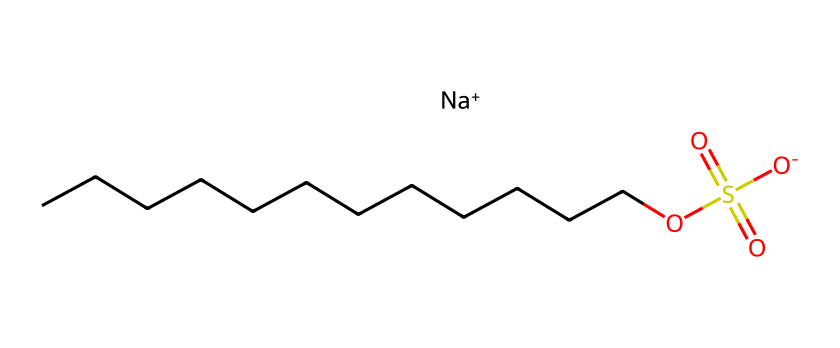What is the molecular formula of sodium dodecyl sulfate? The SMILES representation shows the structure includes sodium (Na), sulfur (S), oxygen (O), and carbon (C). Counting carbon atoms gives 12, so the molecular formula is C12H25NaO4S.
Answer: C12H25NaO4S How many carbon atoms are present in the structure? By examining the hydrophobic tail in the SMILES, which is represented by "CCCCCCCCCCCC," we can see there are 12 carbon atoms.
Answer: 12 What type of chemical bond connects the sodium ion to the sulfate group? The presence of [Na+] indicates an ionic bond between the positively charged sodium ion and the negatively charged sulfate group represented by [O-]S(=O)(=O)O.
Answer: ionic bond How many oxygen atoms are in the sulfate group? The sulfate part of the structure is indicated by "S(=O)(=O)O," which shows three oxygen atoms directly bonded to the sulfur atom, contributing to the sulfate group.
Answer: 4 What is the charge of the sodium ion in sodium dodecyl sulfate? The representation "[Na+]" clearly indicates that the sodium ion carries a positive charge.
Answer: positive What is the role of sodium dodecyl sulfate as a surfactant? Sodium dodecyl sulfate acts as a surfactant by lowering the surface tension of water, enabling better wetting and cleaning properties in detergents.
Answer: surfactant What type of surfactant is sodium dodecyl sulfate categorized as? Given the presence of the negatively charged sulfate group, sodium dodecyl sulfate is categorized as an anionic surfactant.
Answer: anionic 